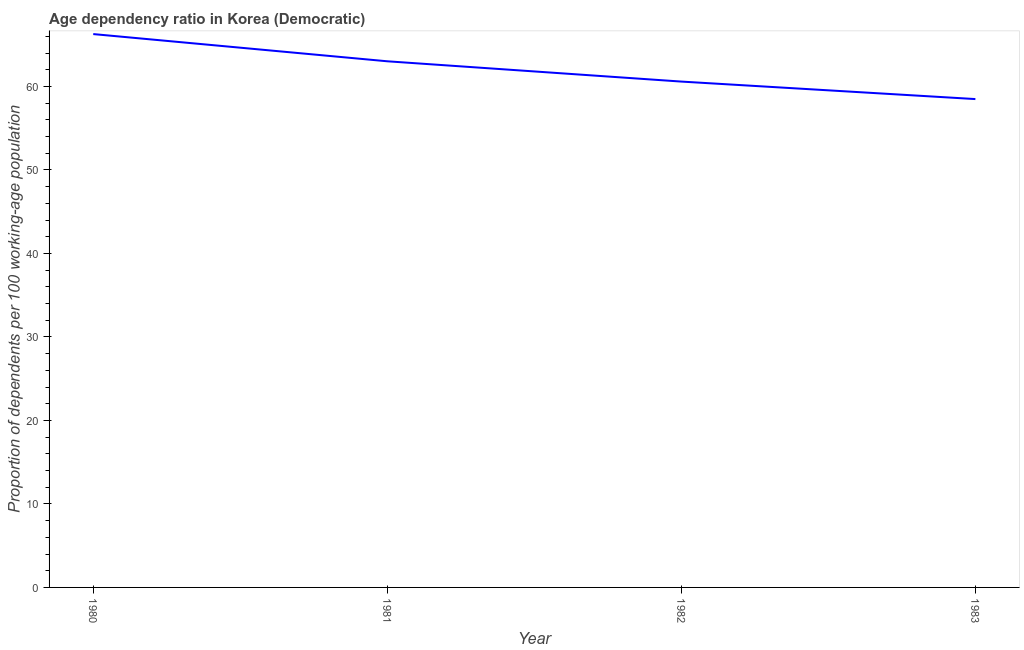What is the age dependency ratio in 1981?
Offer a very short reply. 63.01. Across all years, what is the maximum age dependency ratio?
Provide a succinct answer. 66.27. Across all years, what is the minimum age dependency ratio?
Offer a terse response. 58.49. In which year was the age dependency ratio maximum?
Your response must be concise. 1980. In which year was the age dependency ratio minimum?
Make the answer very short. 1983. What is the sum of the age dependency ratio?
Make the answer very short. 248.35. What is the difference between the age dependency ratio in 1980 and 1981?
Give a very brief answer. 3.26. What is the average age dependency ratio per year?
Keep it short and to the point. 62.09. What is the median age dependency ratio?
Your response must be concise. 61.8. In how many years, is the age dependency ratio greater than 48 ?
Your answer should be compact. 4. Do a majority of the years between 1981 and 1980 (inclusive) have age dependency ratio greater than 24 ?
Give a very brief answer. No. What is the ratio of the age dependency ratio in 1980 to that in 1981?
Give a very brief answer. 1.05. What is the difference between the highest and the second highest age dependency ratio?
Your answer should be very brief. 3.26. Is the sum of the age dependency ratio in 1981 and 1982 greater than the maximum age dependency ratio across all years?
Give a very brief answer. Yes. What is the difference between the highest and the lowest age dependency ratio?
Provide a succinct answer. 7.78. How many lines are there?
Your answer should be very brief. 1. What is the difference between two consecutive major ticks on the Y-axis?
Provide a short and direct response. 10. Does the graph contain any zero values?
Your answer should be very brief. No. What is the title of the graph?
Keep it short and to the point. Age dependency ratio in Korea (Democratic). What is the label or title of the Y-axis?
Your answer should be compact. Proportion of dependents per 100 working-age population. What is the Proportion of dependents per 100 working-age population in 1980?
Offer a very short reply. 66.27. What is the Proportion of dependents per 100 working-age population in 1981?
Keep it short and to the point. 63.01. What is the Proportion of dependents per 100 working-age population in 1982?
Your answer should be very brief. 60.58. What is the Proportion of dependents per 100 working-age population in 1983?
Give a very brief answer. 58.49. What is the difference between the Proportion of dependents per 100 working-age population in 1980 and 1981?
Your response must be concise. 3.26. What is the difference between the Proportion of dependents per 100 working-age population in 1980 and 1982?
Make the answer very short. 5.69. What is the difference between the Proportion of dependents per 100 working-age population in 1980 and 1983?
Keep it short and to the point. 7.78. What is the difference between the Proportion of dependents per 100 working-age population in 1981 and 1982?
Ensure brevity in your answer.  2.43. What is the difference between the Proportion of dependents per 100 working-age population in 1981 and 1983?
Provide a short and direct response. 4.53. What is the difference between the Proportion of dependents per 100 working-age population in 1982 and 1983?
Provide a succinct answer. 2.1. What is the ratio of the Proportion of dependents per 100 working-age population in 1980 to that in 1981?
Make the answer very short. 1.05. What is the ratio of the Proportion of dependents per 100 working-age population in 1980 to that in 1982?
Your response must be concise. 1.09. What is the ratio of the Proportion of dependents per 100 working-age population in 1980 to that in 1983?
Keep it short and to the point. 1.13. What is the ratio of the Proportion of dependents per 100 working-age population in 1981 to that in 1982?
Make the answer very short. 1.04. What is the ratio of the Proportion of dependents per 100 working-age population in 1981 to that in 1983?
Your answer should be compact. 1.08. What is the ratio of the Proportion of dependents per 100 working-age population in 1982 to that in 1983?
Ensure brevity in your answer.  1.04. 